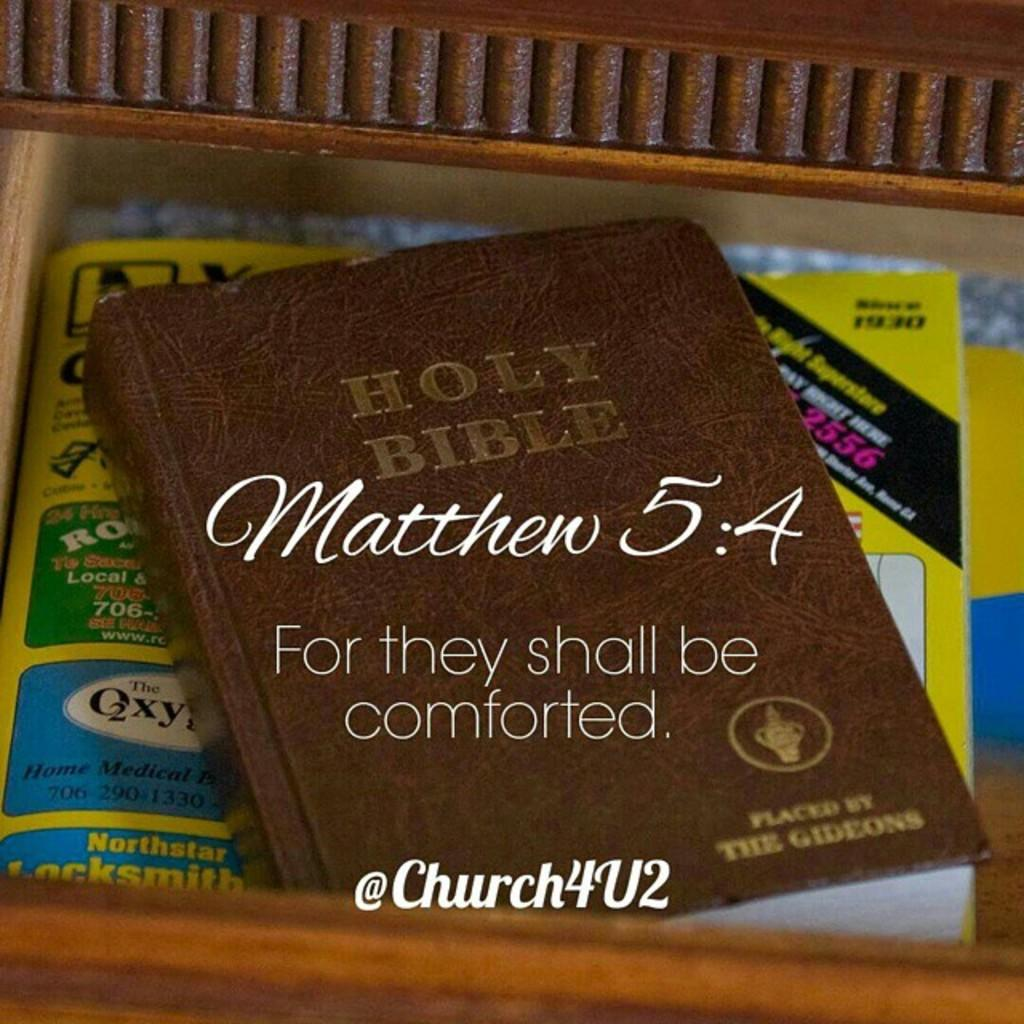<image>
Write a terse but informative summary of the picture. The Holy Bible sits on top of a phone book. 